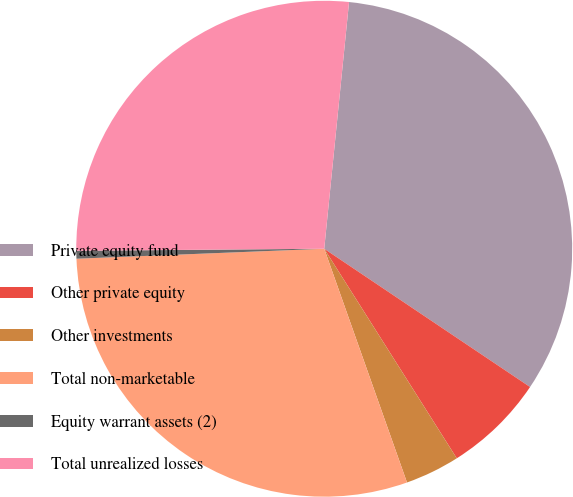Convert chart. <chart><loc_0><loc_0><loc_500><loc_500><pie_chart><fcel>Private equity fund<fcel>Other private equity<fcel>Other investments<fcel>Total non-marketable<fcel>Equity warrant assets (2)<fcel>Total unrealized losses<nl><fcel>32.82%<fcel>6.61%<fcel>3.56%<fcel>29.78%<fcel>0.51%<fcel>26.73%<nl></chart> 